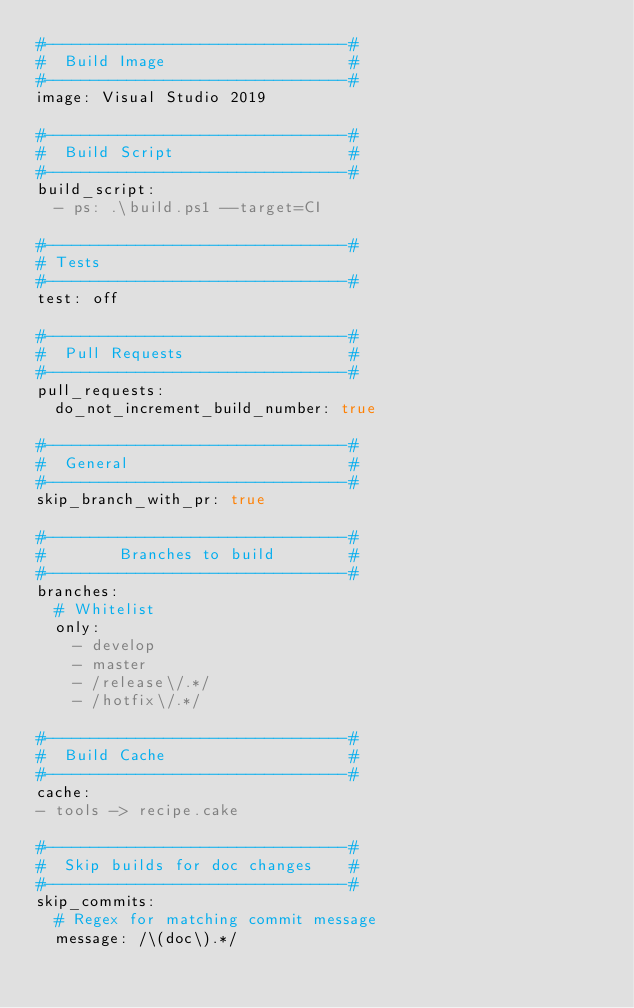Convert code to text. <code><loc_0><loc_0><loc_500><loc_500><_YAML_>#---------------------------------#
#  Build Image                    #
#---------------------------------#
image: Visual Studio 2019

#---------------------------------#
#  Build Script                   #
#---------------------------------#
build_script:
  - ps: .\build.ps1 --target=CI

#---------------------------------#
# Tests
#---------------------------------#
test: off

#---------------------------------#
#  Pull Requests                  #
#---------------------------------#
pull_requests:
  do_not_increment_build_number: true

#---------------------------------#
#  General                        #
#---------------------------------#
skip_branch_with_pr: true

#---------------------------------#
#        Branches to build        #
#---------------------------------#
branches:
  # Whitelist
  only:
    - develop
    - master
    - /release\/.*/
    - /hotfix\/.*/

#---------------------------------#
#  Build Cache                    #
#---------------------------------#
cache:
- tools -> recipe.cake

#---------------------------------#
#  Skip builds for doc changes    #
#---------------------------------#
skip_commits:
  # Regex for matching commit message
  message: /\(doc\).*/
</code> 